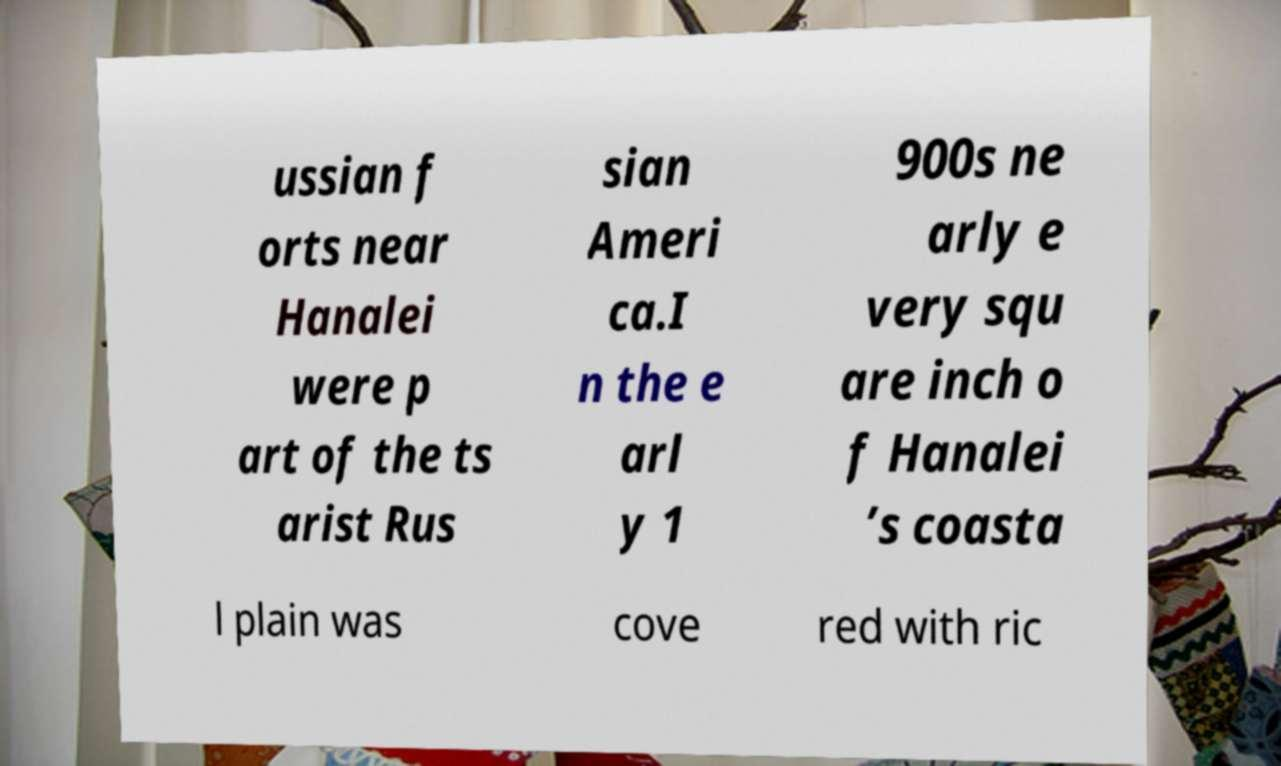Could you extract and type out the text from this image? ussian f orts near Hanalei were p art of the ts arist Rus sian Ameri ca.I n the e arl y 1 900s ne arly e very squ are inch o f Hanalei ’s coasta l plain was cove red with ric 